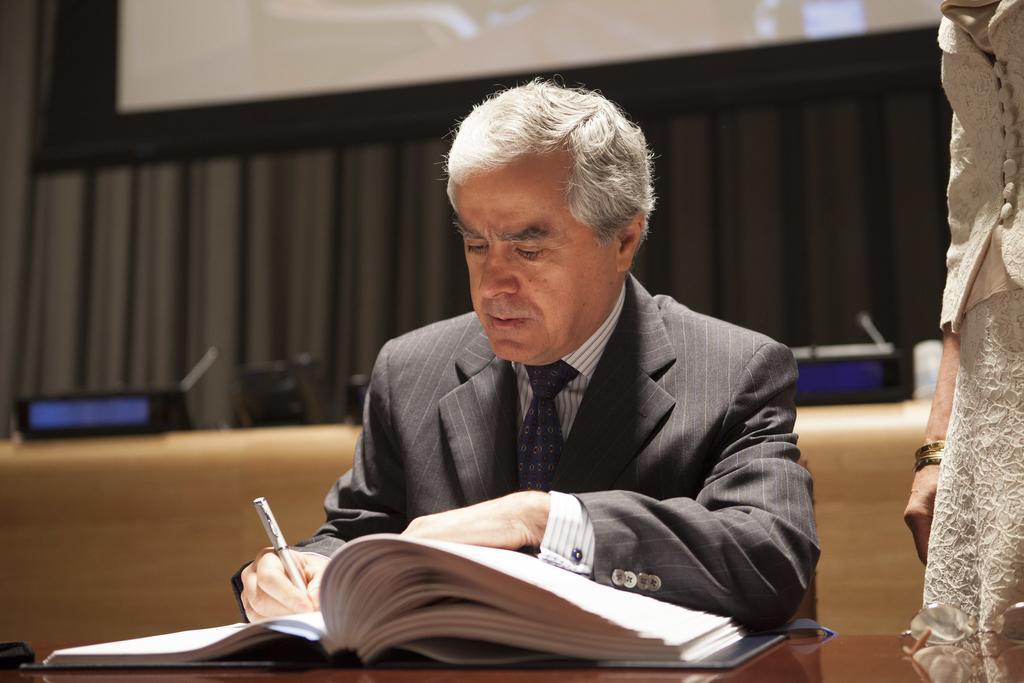Describe this image in one or two sentences. In this image, we can see an old human in a suit is sitting and holding a pen. At the bottom, we can see book and few objects. On the right side of the image, we can see a person. Background we can see the blur view. Here we can see few devices, wooden object, curtains and screen. 